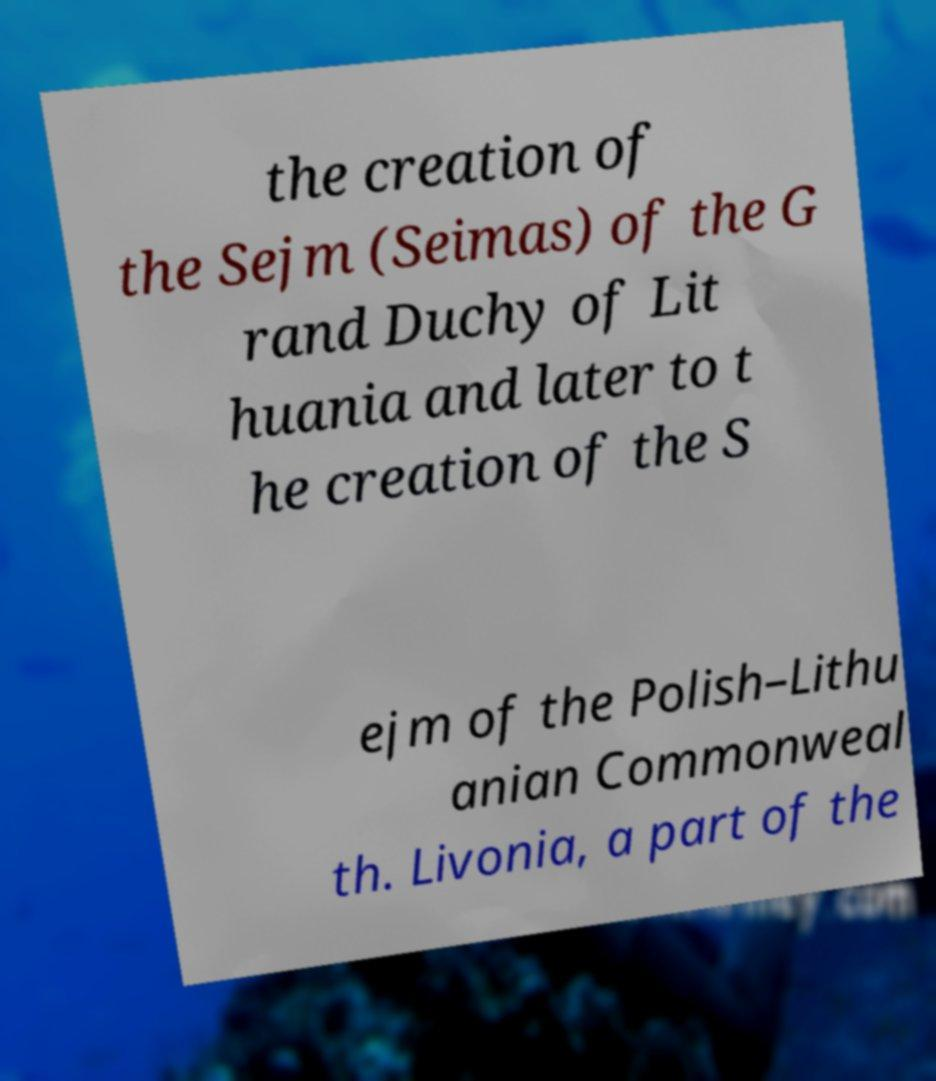For documentation purposes, I need the text within this image transcribed. Could you provide that? the creation of the Sejm (Seimas) of the G rand Duchy of Lit huania and later to t he creation of the S ejm of the Polish–Lithu anian Commonweal th. Livonia, a part of the 